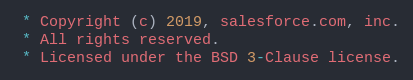<code> <loc_0><loc_0><loc_500><loc_500><_TypeScript_> * Copyright (c) 2019, salesforce.com, inc.
 * All rights reserved.
 * Licensed under the BSD 3-Clause license.</code> 